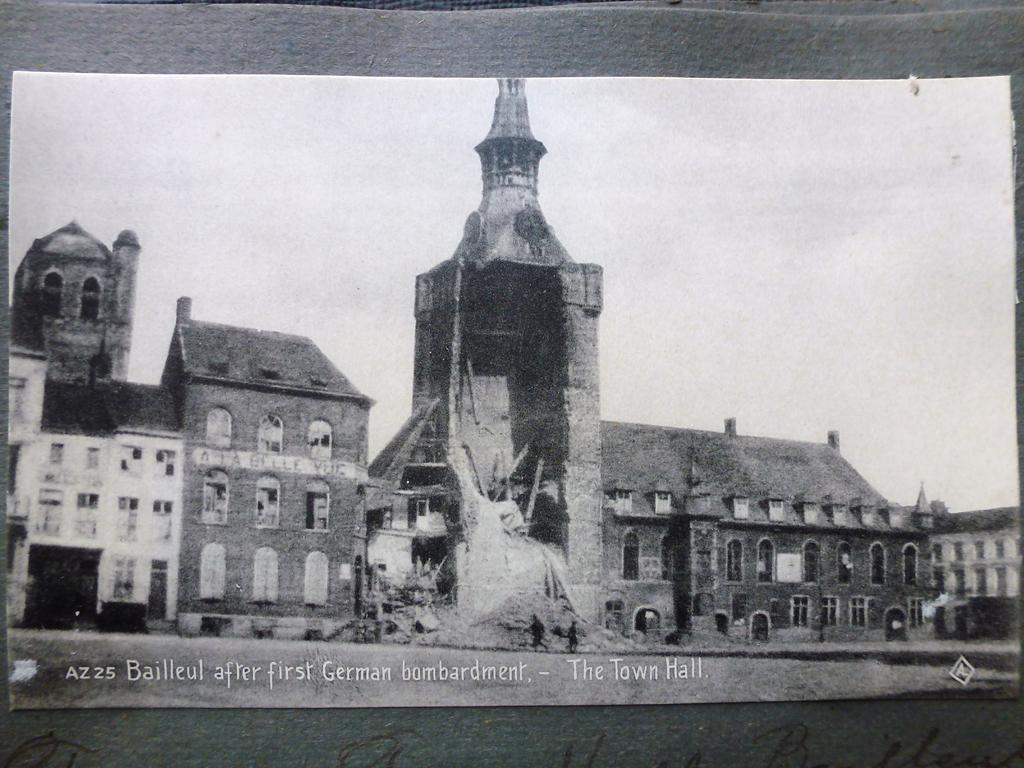How would you summarize this image in a sentence or two? In the image in the center, we can see one poster. On the poster, we can see buildings, windows, poles and two people are walking. In the bottom of the image, there is a watermark. 